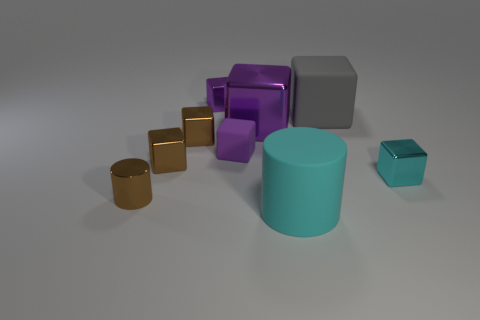Subtract all tiny rubber cubes. How many cubes are left? 6 Subtract all brown cylinders. How many cylinders are left? 1 Add 1 red matte cylinders. How many objects exist? 10 Subtract all purple cylinders. Subtract all gray cubes. How many cylinders are left? 2 Subtract all red cylinders. How many brown blocks are left? 2 Add 6 large purple things. How many large purple things are left? 7 Add 7 gray rubber things. How many gray rubber things exist? 8 Subtract 0 blue spheres. How many objects are left? 9 Subtract all blocks. How many objects are left? 2 Subtract 4 blocks. How many blocks are left? 3 